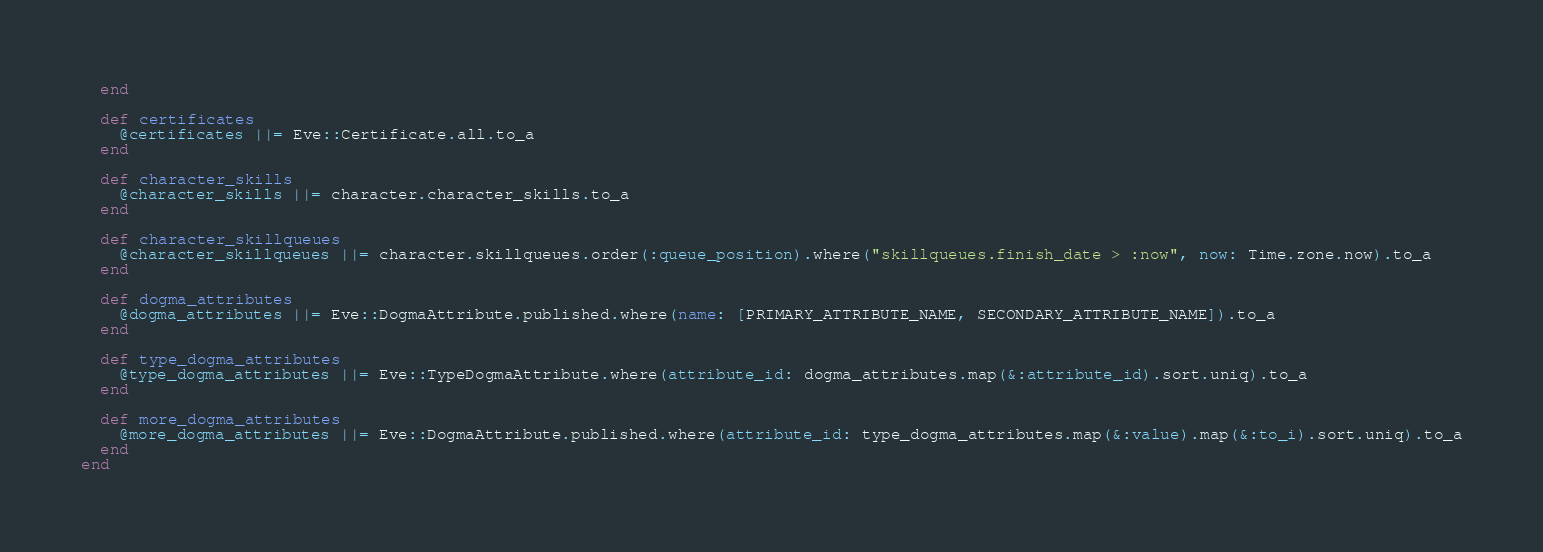Convert code to text. <code><loc_0><loc_0><loc_500><loc_500><_Ruby_>  end

  def certificates
    @certificates ||= Eve::Certificate.all.to_a
  end

  def character_skills
    @character_skills ||= character.character_skills.to_a
  end

  def character_skillqueues
    @character_skillqueues ||= character.skillqueues.order(:queue_position).where("skillqueues.finish_date > :now", now: Time.zone.now).to_a
  end

  def dogma_attributes
    @dogma_attributes ||= Eve::DogmaAttribute.published.where(name: [PRIMARY_ATTRIBUTE_NAME, SECONDARY_ATTRIBUTE_NAME]).to_a
  end

  def type_dogma_attributes
    @type_dogma_attributes ||= Eve::TypeDogmaAttribute.where(attribute_id: dogma_attributes.map(&:attribute_id).sort.uniq).to_a
  end

  def more_dogma_attributes
    @more_dogma_attributes ||= Eve::DogmaAttribute.published.where(attribute_id: type_dogma_attributes.map(&:value).map(&:to_i).sort.uniq).to_a
  end
end
</code> 